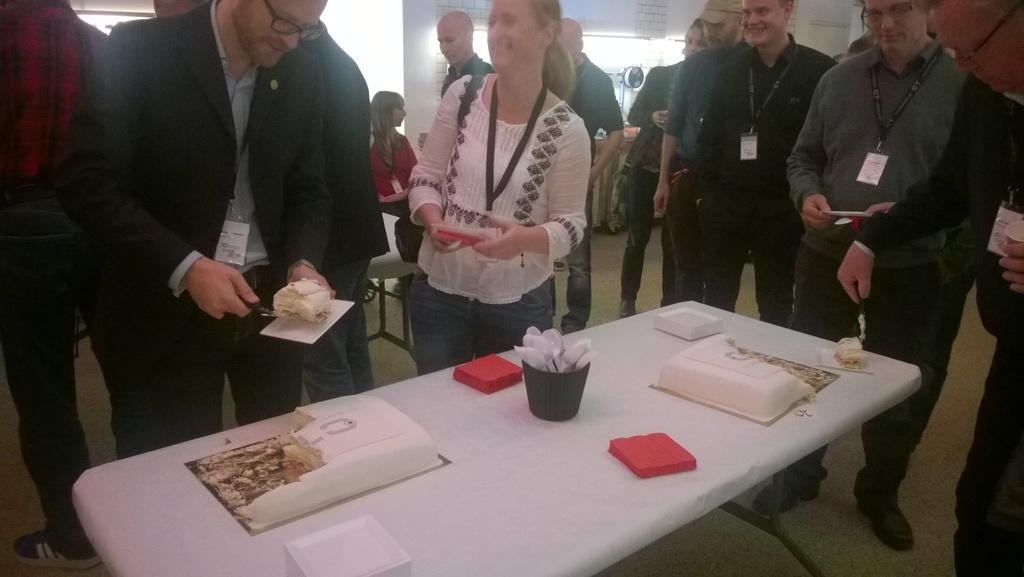What is happening in the image involving the people and the table? There are people standing near a table in the image. What is on the table that might be the focus of attention? There is a cake on the table. What utensils are present on the table? There are spoons on the table. What else might be used for serving or eating food on the table? There are plates on the table. How many wax candles are on the cake in the image? There is no mention of wax candles on the cake in the image. What role does the grandfather play in the image? There is no mention of a grandfather in the image. 